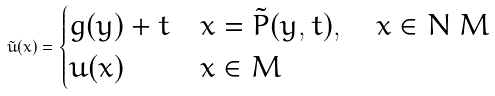<formula> <loc_0><loc_0><loc_500><loc_500>\tilde { u } ( x ) = \begin{cases} g ( y ) + t & x = \tilde { P } ( y , t ) , \quad x \in N \ M \\ u ( x ) & x \in M \end{cases}</formula> 